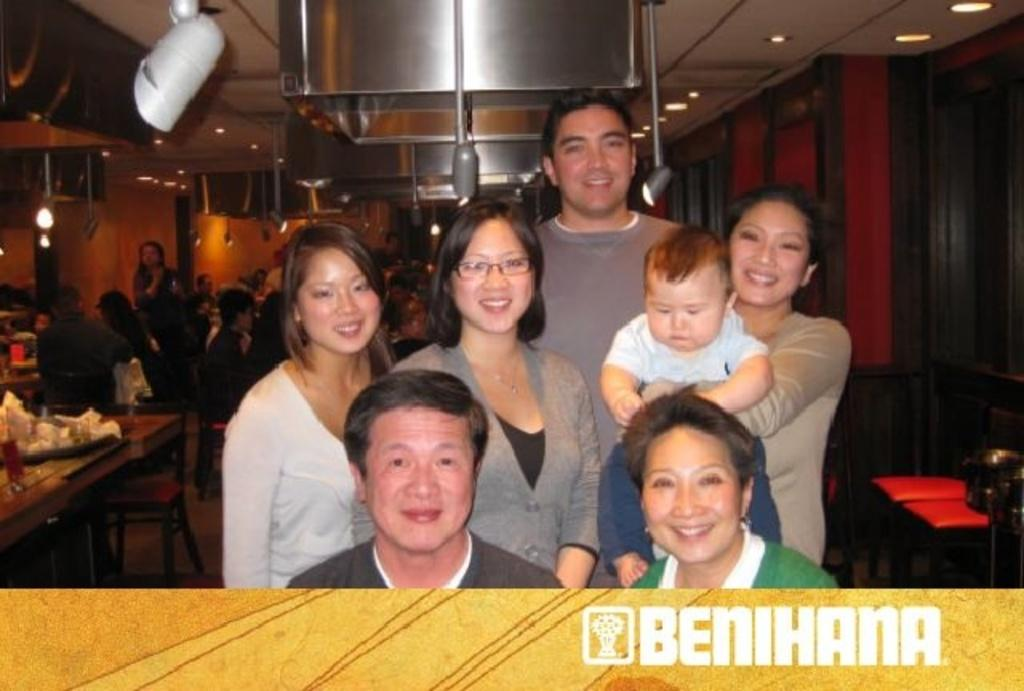How many persons can be seen in the image? There are persons in the image, but the exact number is not specified. What is the facial expression of the persons in the image? The persons in the image are smiling. What type of furniture is visible in the background of the image? There are tables and chairs in the background of the image. What type of lighting is present in the background of the image? There are lights in the background of the image. What type of structure is visible in the background of the image? There is a wall in the background of the image. What type of display device is visible in the background of the image? There is a screen in the background of the image. Are there any additional persons visible in the background of the image? Yes, there are additional persons in the background of the image. What type of bone is being held by the crow in the image? There is no crow or bone present in the image. 